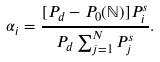<formula> <loc_0><loc_0><loc_500><loc_500>\alpha _ { i } = \frac { [ P _ { d } - P _ { 0 } ( \mathbb { N } ) ] P _ { i } ^ { s } } { P _ { d } \sum _ { j = 1 } ^ { N } P _ { j } ^ { s } } .</formula> 